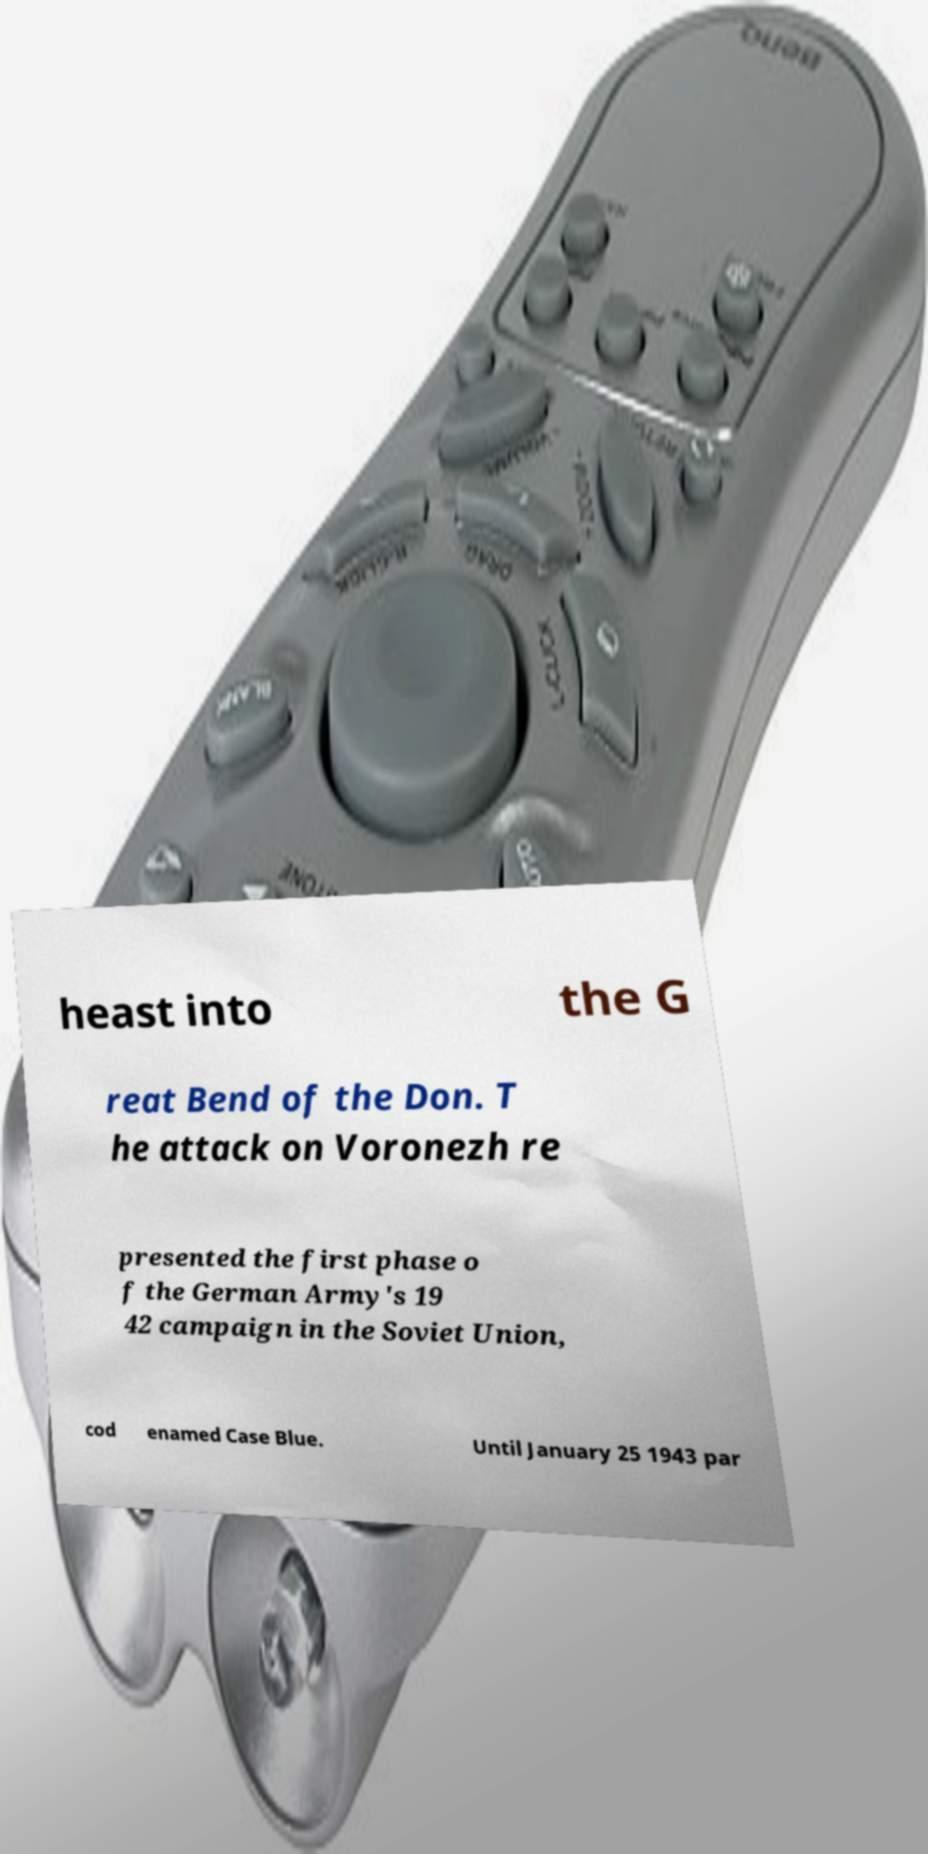Please read and relay the text visible in this image. What does it say? heast into the G reat Bend of the Don. T he attack on Voronezh re presented the first phase o f the German Army's 19 42 campaign in the Soviet Union, cod enamed Case Blue. Until January 25 1943 par 